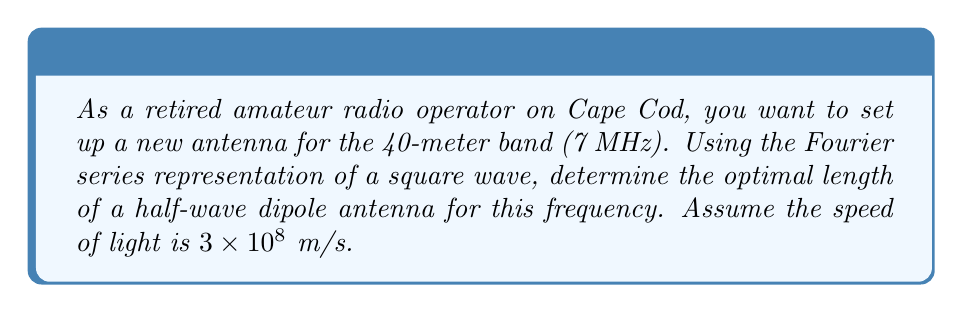Help me with this question. To determine the optimal antenna length, we'll follow these steps:

1) First, recall that the wavelength $\lambda$ is related to the frequency $f$ and the speed of light $c$ by:

   $$\lambda = \frac{c}{f}$$

2) For the given frequency of 7 MHz:

   $$\lambda = \frac{3 \times 10^8 \text{ m/s}}{7 \times 10^6 \text{ Hz}} = 42.86 \text{ m}$$

3) A half-wave dipole antenna has a length of $\frac{\lambda}{2}$. However, we need to consider the Fourier series representation of a square wave to understand why this is optimal.

4) The Fourier series for a square wave is:

   $$f(t) = \frac{4}{\pi} \sum_{n=1,3,5,...}^{\infty} \frac{1}{n} \sin(n\omega t)$$

5) The fundamental frequency (n=1) has the largest amplitude and contributes most to the signal. Higher odd harmonics (n=3,5,7,...) have decreasing amplitudes.

6) A half-wave dipole is resonant at its fundamental frequency and odd harmonics, making it an excellent match for the square wave representation of the signal.

7) Therefore, the optimal length for a half-wave dipole is:

   $$L = \frac{\lambda}{2} = \frac{42.86 \text{ m}}{2} = 21.43 \text{ m}$$

This length ensures that the antenna will efficiently radiate the fundamental frequency and odd harmonics of the signal, maximizing its effectiveness for the 40-meter band.
Answer: The optimal length for a half-wave dipole antenna for the 40-meter band (7 MHz) is 21.43 meters. 